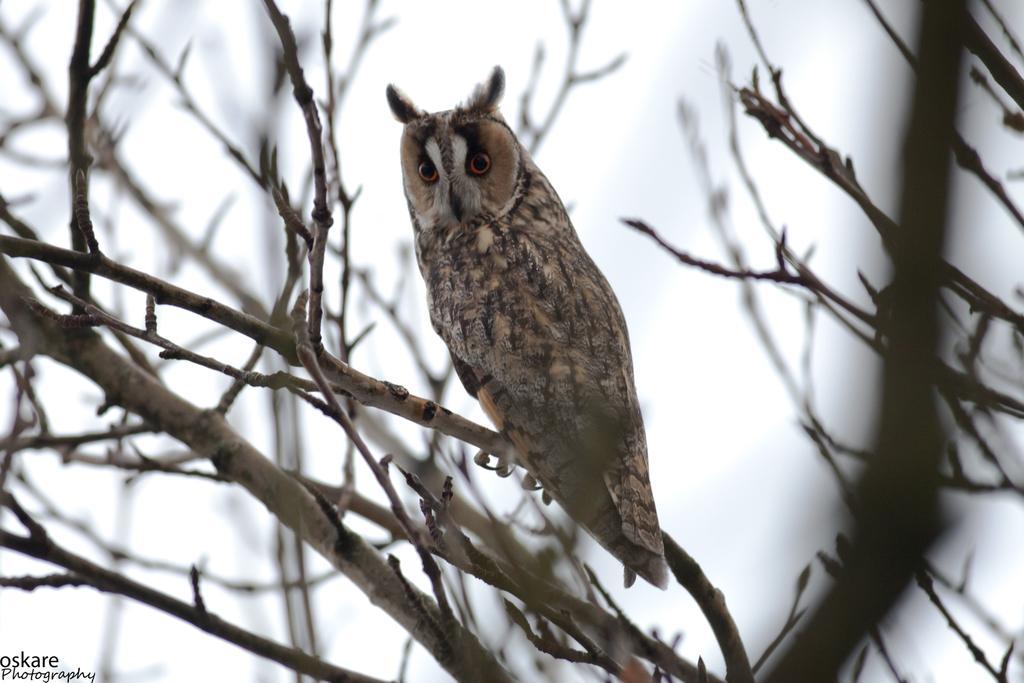How would you summarize this image in a sentence or two? In this image we can see an owl on a branch of a tree. In the background we can see the sky. On the left side at the bottom corner there is a text on the image. 